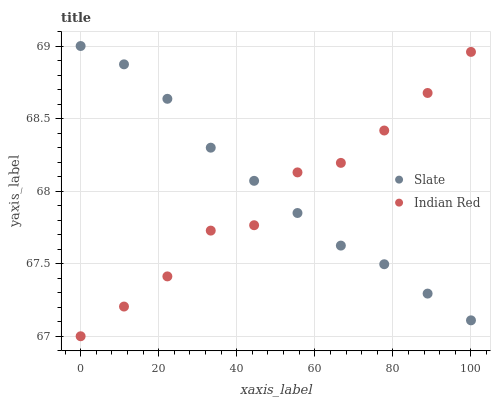Does Indian Red have the minimum area under the curve?
Answer yes or no. Yes. Does Slate have the maximum area under the curve?
Answer yes or no. Yes. Does Indian Red have the maximum area under the curve?
Answer yes or no. No. Is Slate the smoothest?
Answer yes or no. Yes. Is Indian Red the roughest?
Answer yes or no. Yes. Is Indian Red the smoothest?
Answer yes or no. No. Does Indian Red have the lowest value?
Answer yes or no. Yes. Does Slate have the highest value?
Answer yes or no. Yes. Does Indian Red have the highest value?
Answer yes or no. No. Does Indian Red intersect Slate?
Answer yes or no. Yes. Is Indian Red less than Slate?
Answer yes or no. No. Is Indian Red greater than Slate?
Answer yes or no. No. 